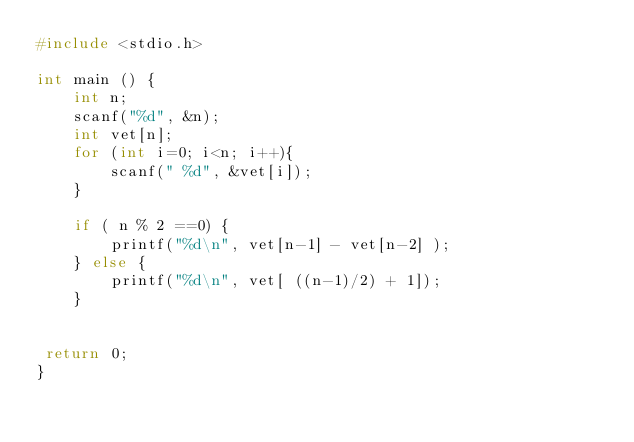<code> <loc_0><loc_0><loc_500><loc_500><_C_>#include <stdio.h>

int main () {
    int n;
    scanf("%d", &n);
    int vet[n];
    for (int i=0; i<n; i++){
        scanf(" %d", &vet[i]);
    }

    if ( n % 2 ==0) {
        printf("%d\n", vet[n-1] - vet[n-2] );
    } else {
        printf("%d\n", vet[ ((n-1)/2) + 1]);
    }


 return 0;
}
</code> 